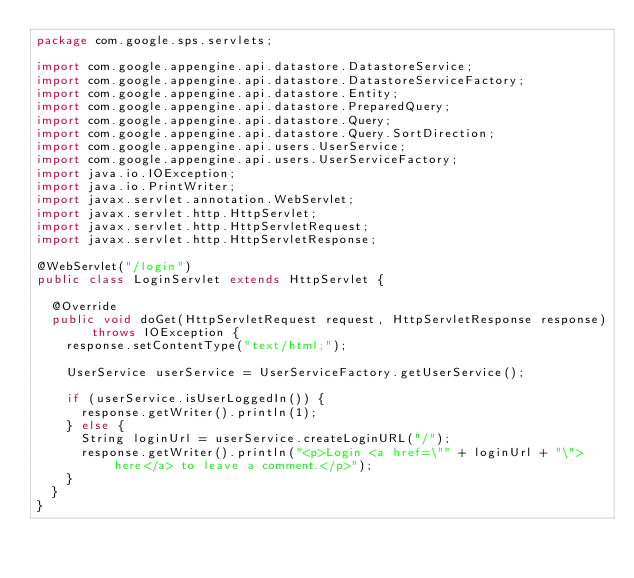<code> <loc_0><loc_0><loc_500><loc_500><_Java_>package com.google.sps.servlets;

import com.google.appengine.api.datastore.DatastoreService;
import com.google.appengine.api.datastore.DatastoreServiceFactory;
import com.google.appengine.api.datastore.Entity;
import com.google.appengine.api.datastore.PreparedQuery;
import com.google.appengine.api.datastore.Query;
import com.google.appengine.api.datastore.Query.SortDirection;
import com.google.appengine.api.users.UserService;
import com.google.appengine.api.users.UserServiceFactory;
import java.io.IOException;
import java.io.PrintWriter;
import javax.servlet.annotation.WebServlet;
import javax.servlet.http.HttpServlet;
import javax.servlet.http.HttpServletRequest;
import javax.servlet.http.HttpServletResponse;

@WebServlet("/login")
public class LoginServlet extends HttpServlet {

  @Override
  public void doGet(HttpServletRequest request, HttpServletResponse response) throws IOException {
    response.setContentType("text/html;");

    UserService userService = UserServiceFactory.getUserService();

    if (userService.isUserLoggedIn()) {
      response.getWriter().println(1);
    } else {
      String loginUrl = userService.createLoginURL("/");
      response.getWriter().println("<p>Login <a href=\"" + loginUrl + "\">here</a> to leave a comment.</p>");
    }      
  }
}
</code> 